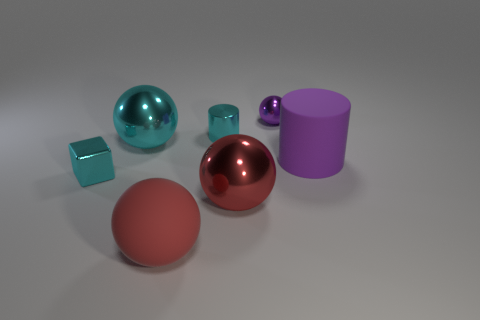What number of cyan shiny things are the same shape as the purple matte thing?
Offer a terse response. 1. Does the small cyan thing that is in front of the matte cylinder have the same material as the cylinder that is right of the tiny cylinder?
Make the answer very short. No. There is a cyan object right of the big ball that is behind the large red shiny object; how big is it?
Your answer should be very brief. Small. Are there any other things that are the same size as the rubber cylinder?
Your answer should be very brief. Yes. What material is the purple object that is the same shape as the big cyan thing?
Your answer should be very brief. Metal. There is a tiny metal thing on the right side of the shiny cylinder; is its shape the same as the big shiny object that is behind the large red metal thing?
Offer a very short reply. Yes. Is the number of blocks greater than the number of large yellow shiny cubes?
Make the answer very short. Yes. The purple cylinder is what size?
Make the answer very short. Large. How many other things are there of the same color as the rubber cylinder?
Give a very brief answer. 1. Do the small object to the right of the large red metallic sphere and the large purple thing have the same material?
Give a very brief answer. No. 